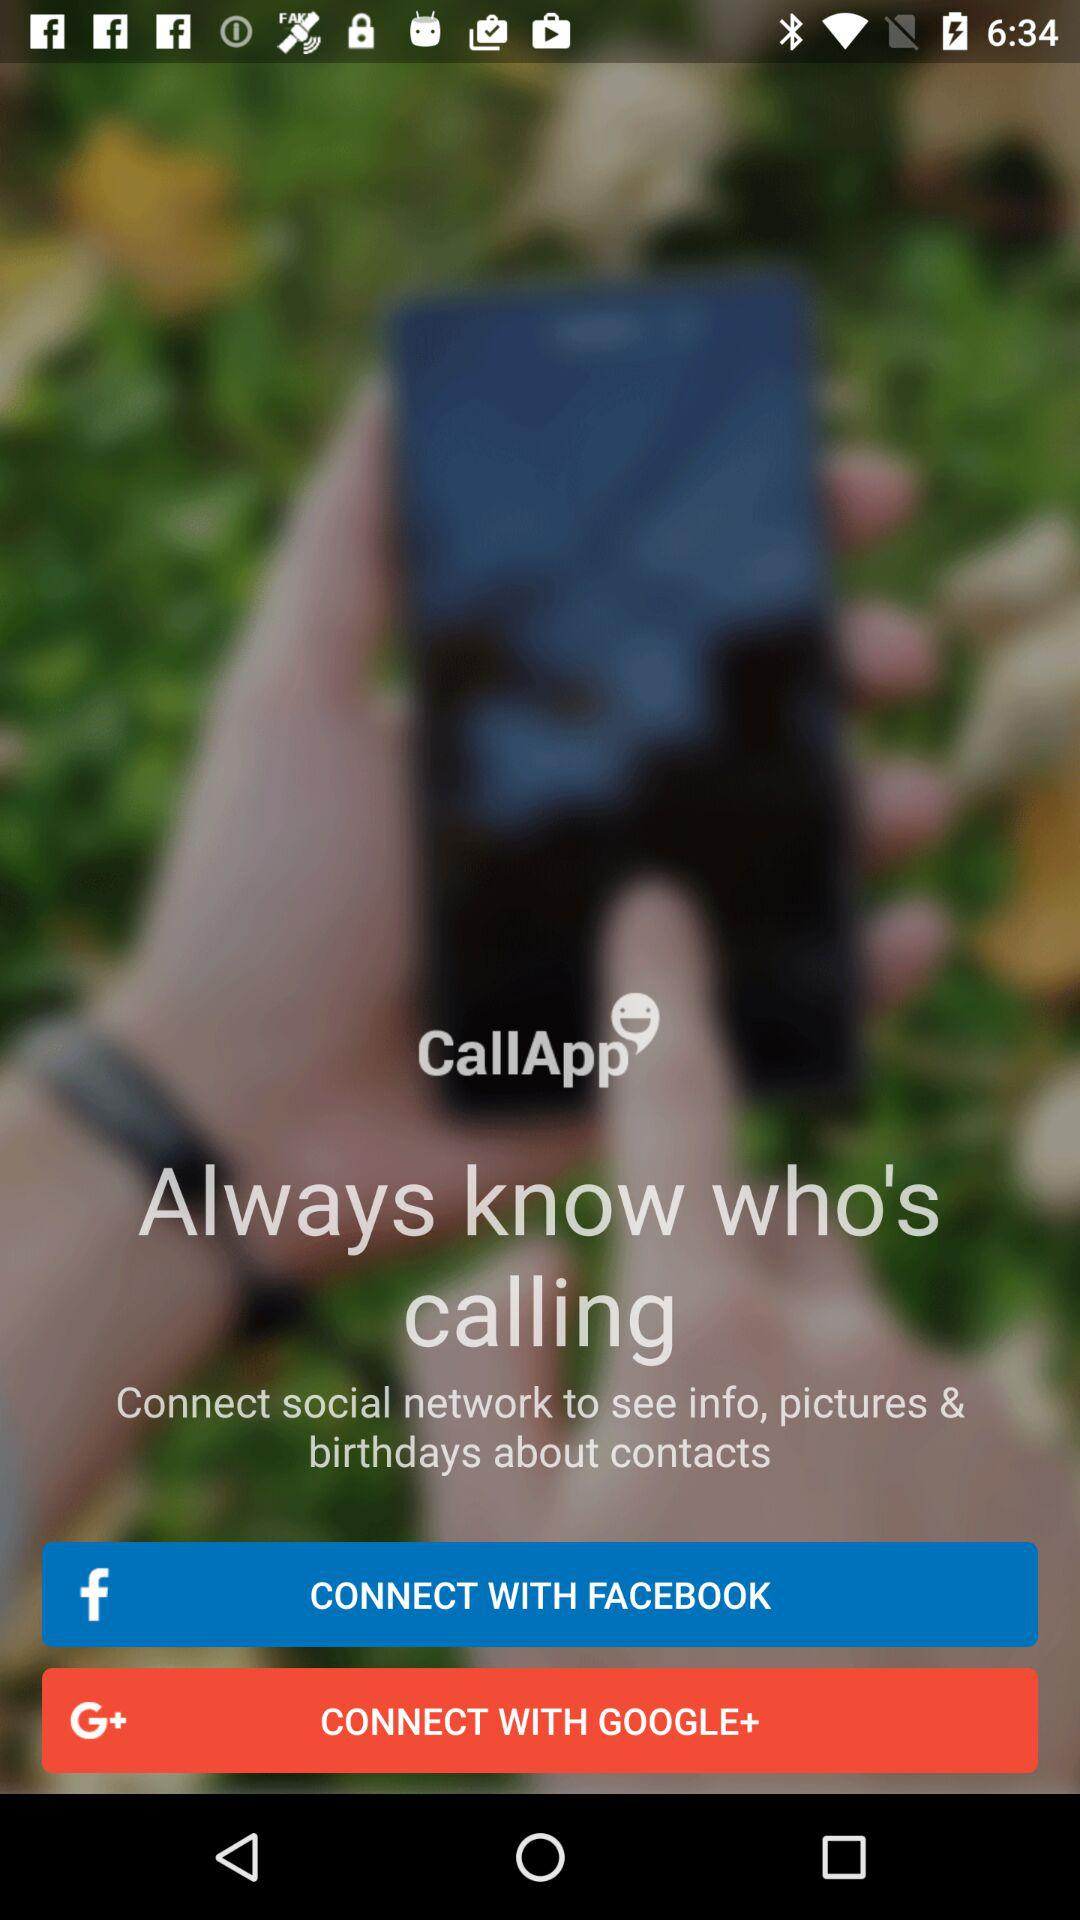What are the different options through which we can connect? You can connect through "FACEBOOK" and "GOOGLE+". 